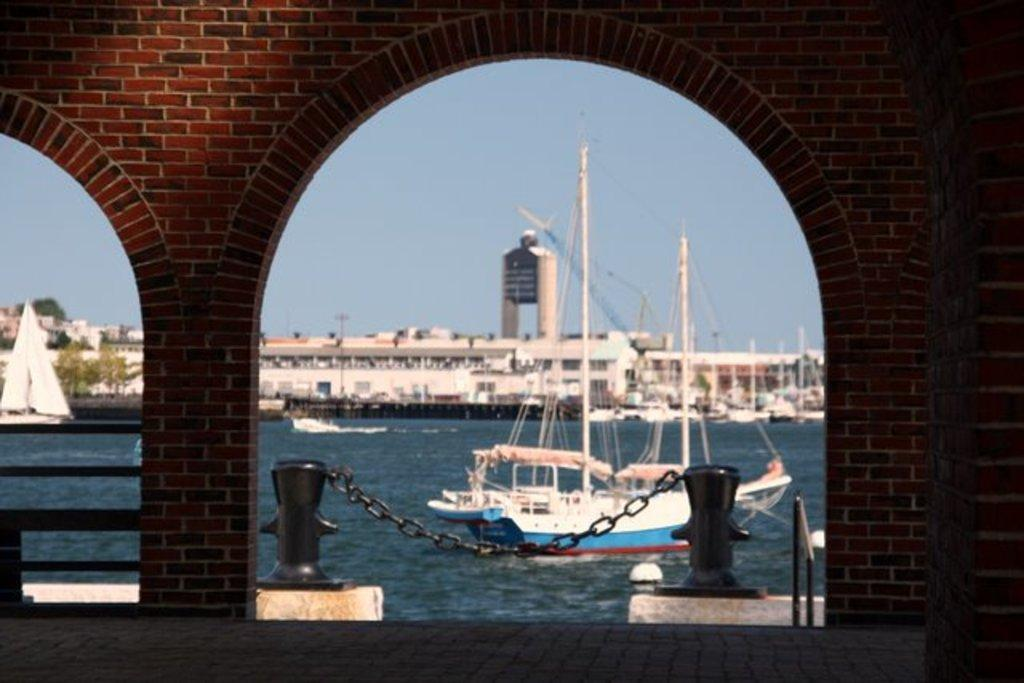What type of wall is present in the image? There is a red color bricks wall in the image. What body of water can be seen in the image? There is a lake in the image. What is floating on the lake? A ship is visible in the lake. What type of structure is present in the image? There is a building in the image. What part of the natural environment is visible in the image? The sky is visible in the image. How does the ship get the attention of the people in the image? There are no people present in the image, so it is not possible to determine how the ship gets their attention. What type of slip is present near the lake in the image? There is no slip present near the lake in the image. 